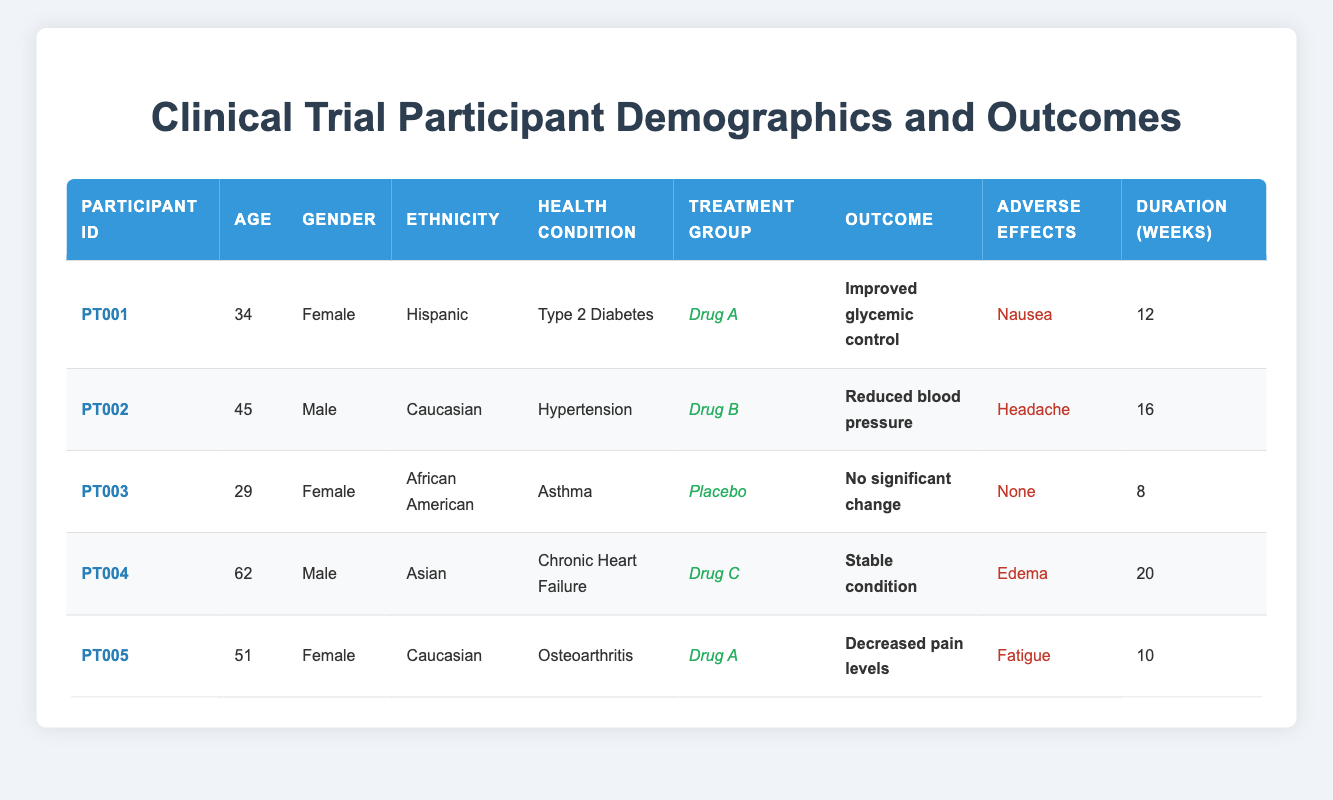What is the average age of participants in the clinical trial? To find the average age, I need to sum the ages of all participants and then divide by the number of participants. The ages are 34, 45, 29, 62, and 51. The sum is 34 + 45 + 29 + 62 + 51 = 221. There are 5 participants, so the average age is 221 / 5 = 44.2.
Answer: 44.2 How many participants were treated with Drug A? I can see from the table that Drug A was prescribed to two participants: PT001 and PT005.
Answer: 2 Did any participant experience nausea as an adverse effect? Looking at the table, PT001 had nausea listed as an adverse effect. Therefore, the answer is yes.
Answer: Yes What is the outcome reported by the participant who was 62 years old? The participant who was 62 years old is PT004, and the outcome listed for this participant is "Stable condition."
Answer: Stable condition Which treatment group had the participant with the highest age? The participant with the highest age is PT004, who is 62 years old and belongs to the treatment group "Drug C."
Answer: Drug C What is the participation duration for the participant that had reduced blood pressure? The participant who experienced reduced blood pressure is PT002, and their participation duration was 16 weeks.
Answer: 16 weeks Is there any participant that had "no significant change" in outcome? Yes, PT003 reported "No significant change" as their outcome.
Answer: Yes What was the most common gender among the participants? There are three females (PT001, PT003, PT005) and two males (PT002, PT004). Since there are more females than males, the most common gender among the participants is female.
Answer: Female Which health condition had the youngest participant? The youngest participant is PT003, who is 29 years old and has asthma as their health condition.
Answer: Asthma 